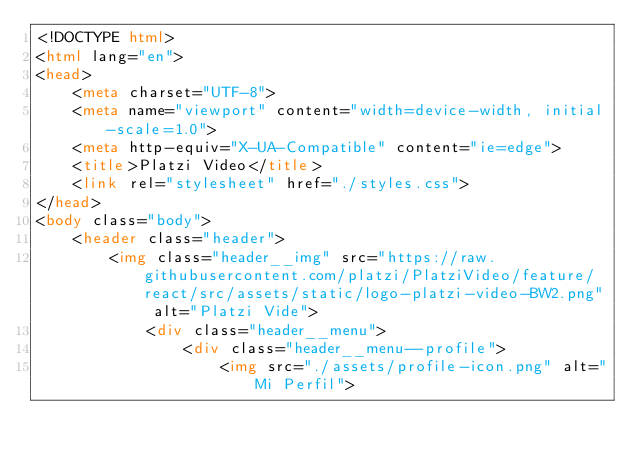Convert code to text. <code><loc_0><loc_0><loc_500><loc_500><_HTML_><!DOCTYPE html>
<html lang="en">
<head>
    <meta charset="UTF-8">
    <meta name="viewport" content="width=device-width, initial-scale=1.0">
    <meta http-equiv="X-UA-Compatible" content="ie=edge">
    <title>Platzi Video</title>
    <link rel="stylesheet" href="./styles.css">
</head>
<body class="body">
    <header class="header">
        <img class="header__img" src="https://raw.githubusercontent.com/platzi/PlatziVideo/feature/react/src/assets/static/logo-platzi-video-BW2.png" alt="Platzi Vide">
            <div class="header__menu">
                <div class="header__menu--profile">
                    <img src="./assets/profile-icon.png" alt="Mi Perfil"></code> 